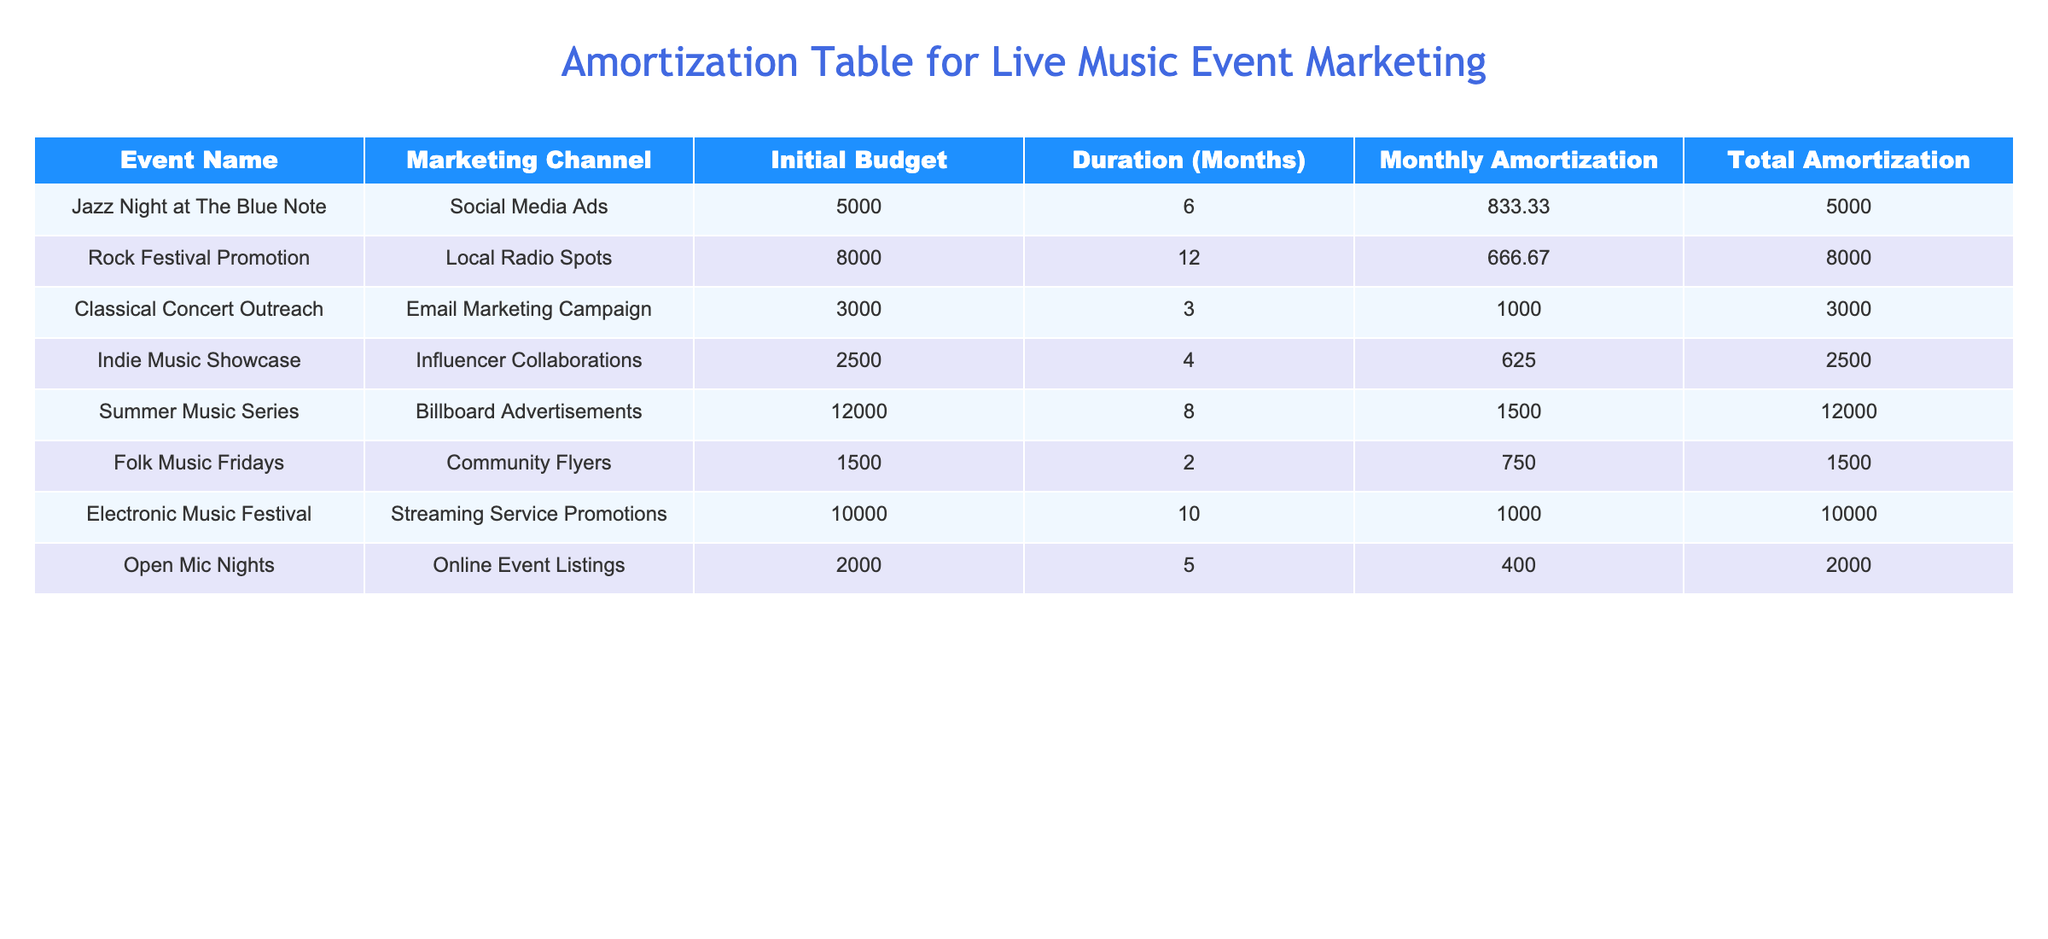What is the total amortization for the 'Jazz Night at The Blue Note'? The total amortization can be found in the corresponding row of the table for 'Jazz Night at The Blue Note', which shows '5000' as the value.
Answer: 5000 How many months is the marketing budget for the 'Electronic Music Festival'? The duration for 'Electronic Music Festival' is readily visible in the table, which indicates it is '10' months long.
Answer: 10 What is the initial budget for the 'Indie Music Showcase'? The initial budget for the 'Indie Music Showcase' is shown in the table as '2500'.
Answer: 2500 Which marketing channel has the highest monthly amortization? To find the highest monthly amortization, we compare the monthly amortization values in the table. 'Summer Music Series' shows a monthly amortization of '1500', which is the highest value.
Answer: Summer Music Series If we combine the total amortization of the 'Rock Festival Promotion' and 'Classic Concert Outreach', what is the result? The total amortization for 'Rock Festival Promotion' is '8000' and for 'Classical Concert Outreach' is '3000'. Adding these two gives: 8000 + 3000 = 11000.
Answer: 11000 Does the 'Folk Music Fridays' have a higher initial budget than 'Open Mic Nights'? The initial budget for 'Folk Music Fridays' is '1500', while for 'Open Mic Nights' it is '2000'. Since '1500' is less than '2000', the answer is no.
Answer: No What is the average duration of the marketing budgets for all events? To find the average duration, we sum the durations of all events: 6 + 12 + 3 + 4 + 8 + 2 + 10 + 5 = 50 months. There are 8 events, so the average duration is 50/8 = 6.25 months.
Answer: 6.25 Which marketing channel was used for the least initial budget and what is that budget? The table shows that 'Folk Music Fridays' uses 'Community Flyers' and has the least initial budget listed at '1500'.
Answer: Community Flyers, 1500 What is the total monthly amortization for all events combined? We add all the monthly amortization values from the table: 833.33 + 666.67 + 1000.00 + 625.00 + 1500.00 + 750.00 + 1000.00 + 400.00 = 5000.00.
Answer: 5000.00 